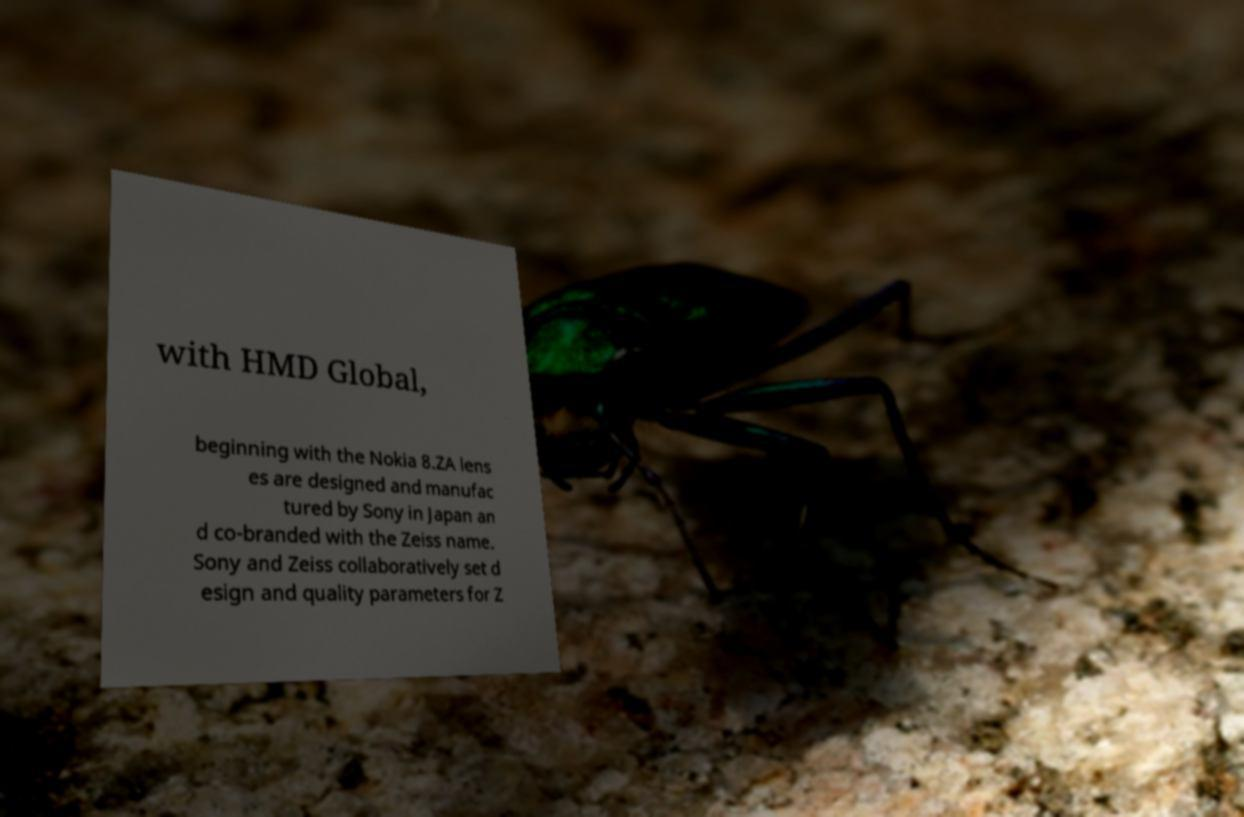There's text embedded in this image that I need extracted. Can you transcribe it verbatim? with HMD Global, beginning with the Nokia 8.ZA lens es are designed and manufac tured by Sony in Japan an d co-branded with the Zeiss name. Sony and Zeiss collaboratively set d esign and quality parameters for Z 